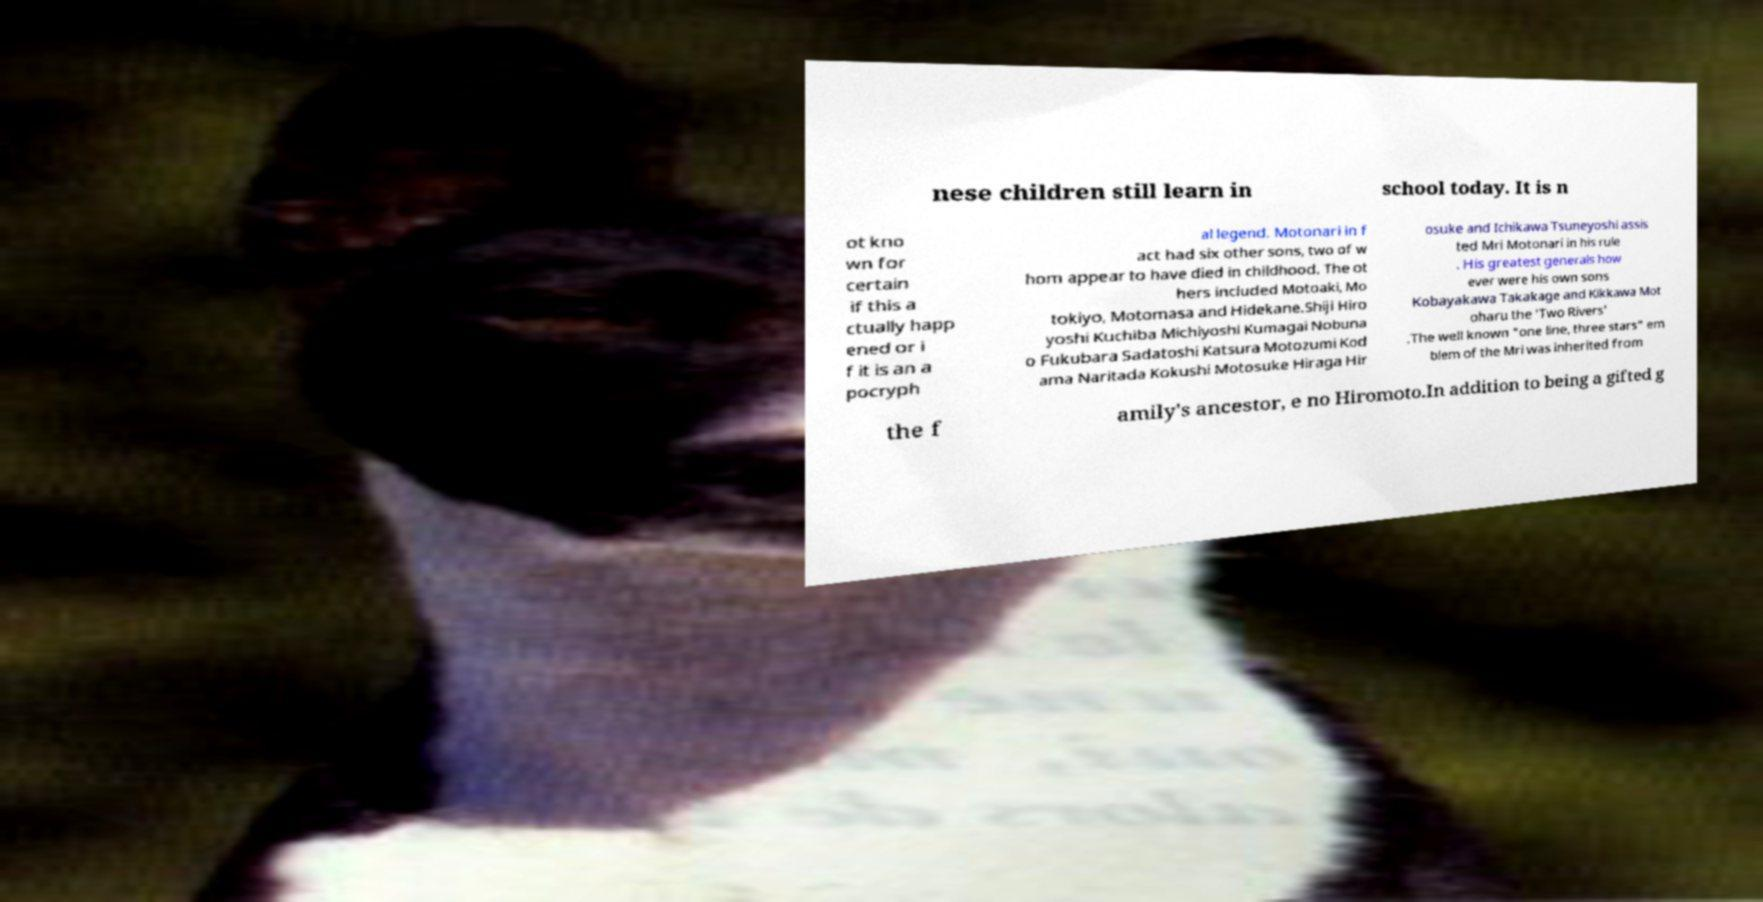I need the written content from this picture converted into text. Can you do that? nese children still learn in school today. It is n ot kno wn for certain if this a ctually happ ened or i f it is an a pocryph al legend. Motonari in f act had six other sons, two of w hom appear to have died in childhood. The ot hers included Motoaki, Mo tokiyo, Motomasa and Hidekane.Shiji Hiro yoshi Kuchiba Michiyoshi Kumagai Nobuna o Fukubara Sadatoshi Katsura Motozumi Kod ama Naritada Kokushi Motosuke Hiraga Hir osuke and Ichikawa Tsuneyoshi assis ted Mri Motonari in his rule . His greatest generals how ever were his own sons Kobayakawa Takakage and Kikkawa Mot oharu the 'Two Rivers' .The well known "one line, three stars" em blem of the Mri was inherited from the f amily's ancestor, e no Hiromoto.In addition to being a gifted g 